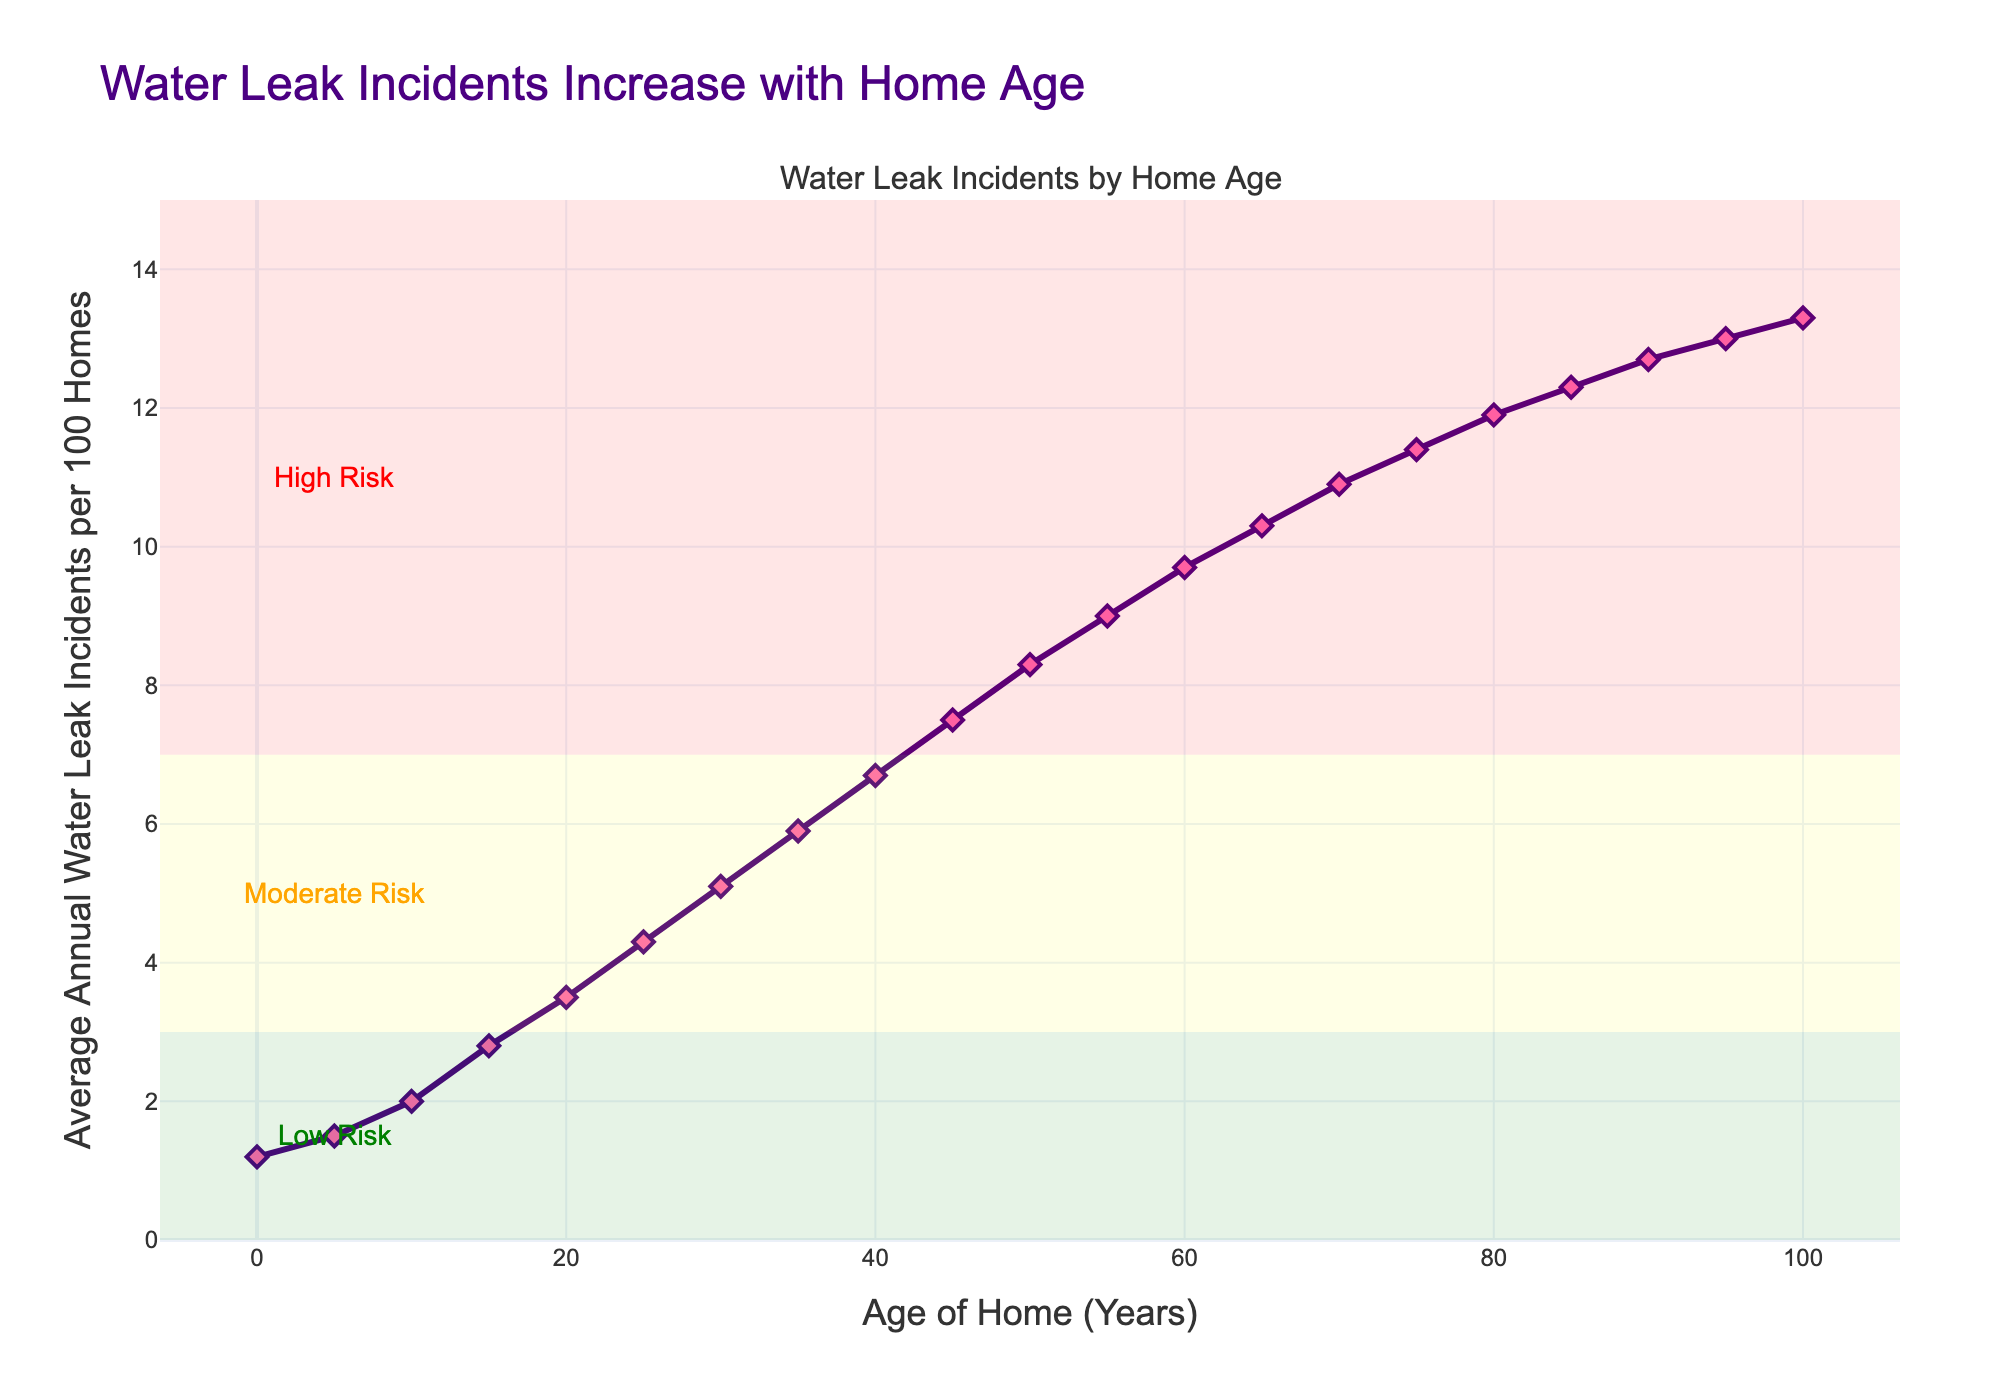What is the frequency of water leak incidents in homes that are 50 years old? According to the chart, at the 50-year mark, the y-axis value (Average Annual Water Leak Incidents per 100 Homes) is directly given, which shows 8.3 incidents per 100 homes.
Answer: 8.3 How many more leak incidents per year happen in 100 homes that are 75 years old compared to 25 years old? For 75-year-old homes, the y-axis value is 11.4 incidents, and for 25-year-old homes, it is 4.3 incidents. Subtracting the two gives 11.4 - 4.3 = 7.1 additional incidents per year.
Answer: 7.1 Between which age ranges does the risk of water leaks change from moderate to high? By looking at the shaded regions and the markings, the moderate risk area ends at roughly 7 incidents per 100 homes, and the high-risk area starts just above that. The shift occurs between the 45-year mark (7.5 incidents) and the 50-year mark (8.3 incidents).
Answer: 45 - 50 years In how many years does the frequency of water leaks cross from low risk to moderate risk? The low-risk area ends at 3 incidents per 100 homes, and the moderate-risk starts just above this. The 15-year mark shows 2.8 incidents, while the 20-year mark shows 3.5 incidents. The transition happens between the 15 and 20-year marks.
Answer: 15 - 20 years How much does the frequency of water leaks increase on average every 10 years for homes between 0 and 50 years old? To find the average increase, take the frequency at 50 years (8.3 incidents) and subtract it from the frequency at 0 years (1.2 incidents), and then divide by the number of 10-year intervals (5 intervals). \((8.3 - 1.2)/5 = 1.42 incidents\).
Answer: 1.42 incidents per 10 years Which age of home has the highest frequency of water leaks? By looking at the peak of the y-axis values on the chart, homes that are 100 years old have the highest frequency with 13.3 incidents per 100 homes.
Answer: 100 years At what home age does the frequency of water leaks first reach 10 incidents per 100 homes? Looking at the chart, the first time the frequency reaches 10 incidents is at the 65-year mark, where the y-axis value is 10.3 incidents.
Answer: 65 years How does the frequency of water leaks in homes that are 40 years old compare to those that are 85 years old? The chart shows that 40-year-old homes have 6.7 incidents per 100 homes, while 85-year-old homes have 12.3 incidents. The 85-year-old homes have 5.6 more incidents per 100 homes.
Answer: 12.3 is 5.6 more than 6.7 